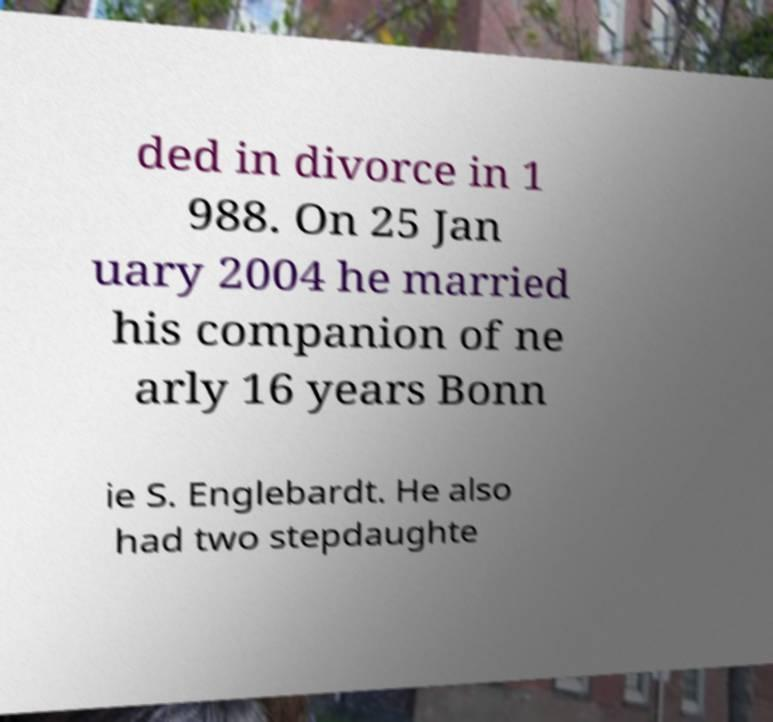Can you read and provide the text displayed in the image?This photo seems to have some interesting text. Can you extract and type it out for me? ded in divorce in 1 988. On 25 Jan uary 2004 he married his companion of ne arly 16 years Bonn ie S. Englebardt. He also had two stepdaughte 